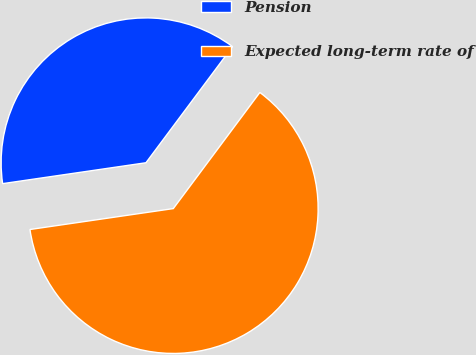<chart> <loc_0><loc_0><loc_500><loc_500><pie_chart><fcel>Pension<fcel>Expected long-term rate of<nl><fcel>37.5%<fcel>62.5%<nl></chart> 